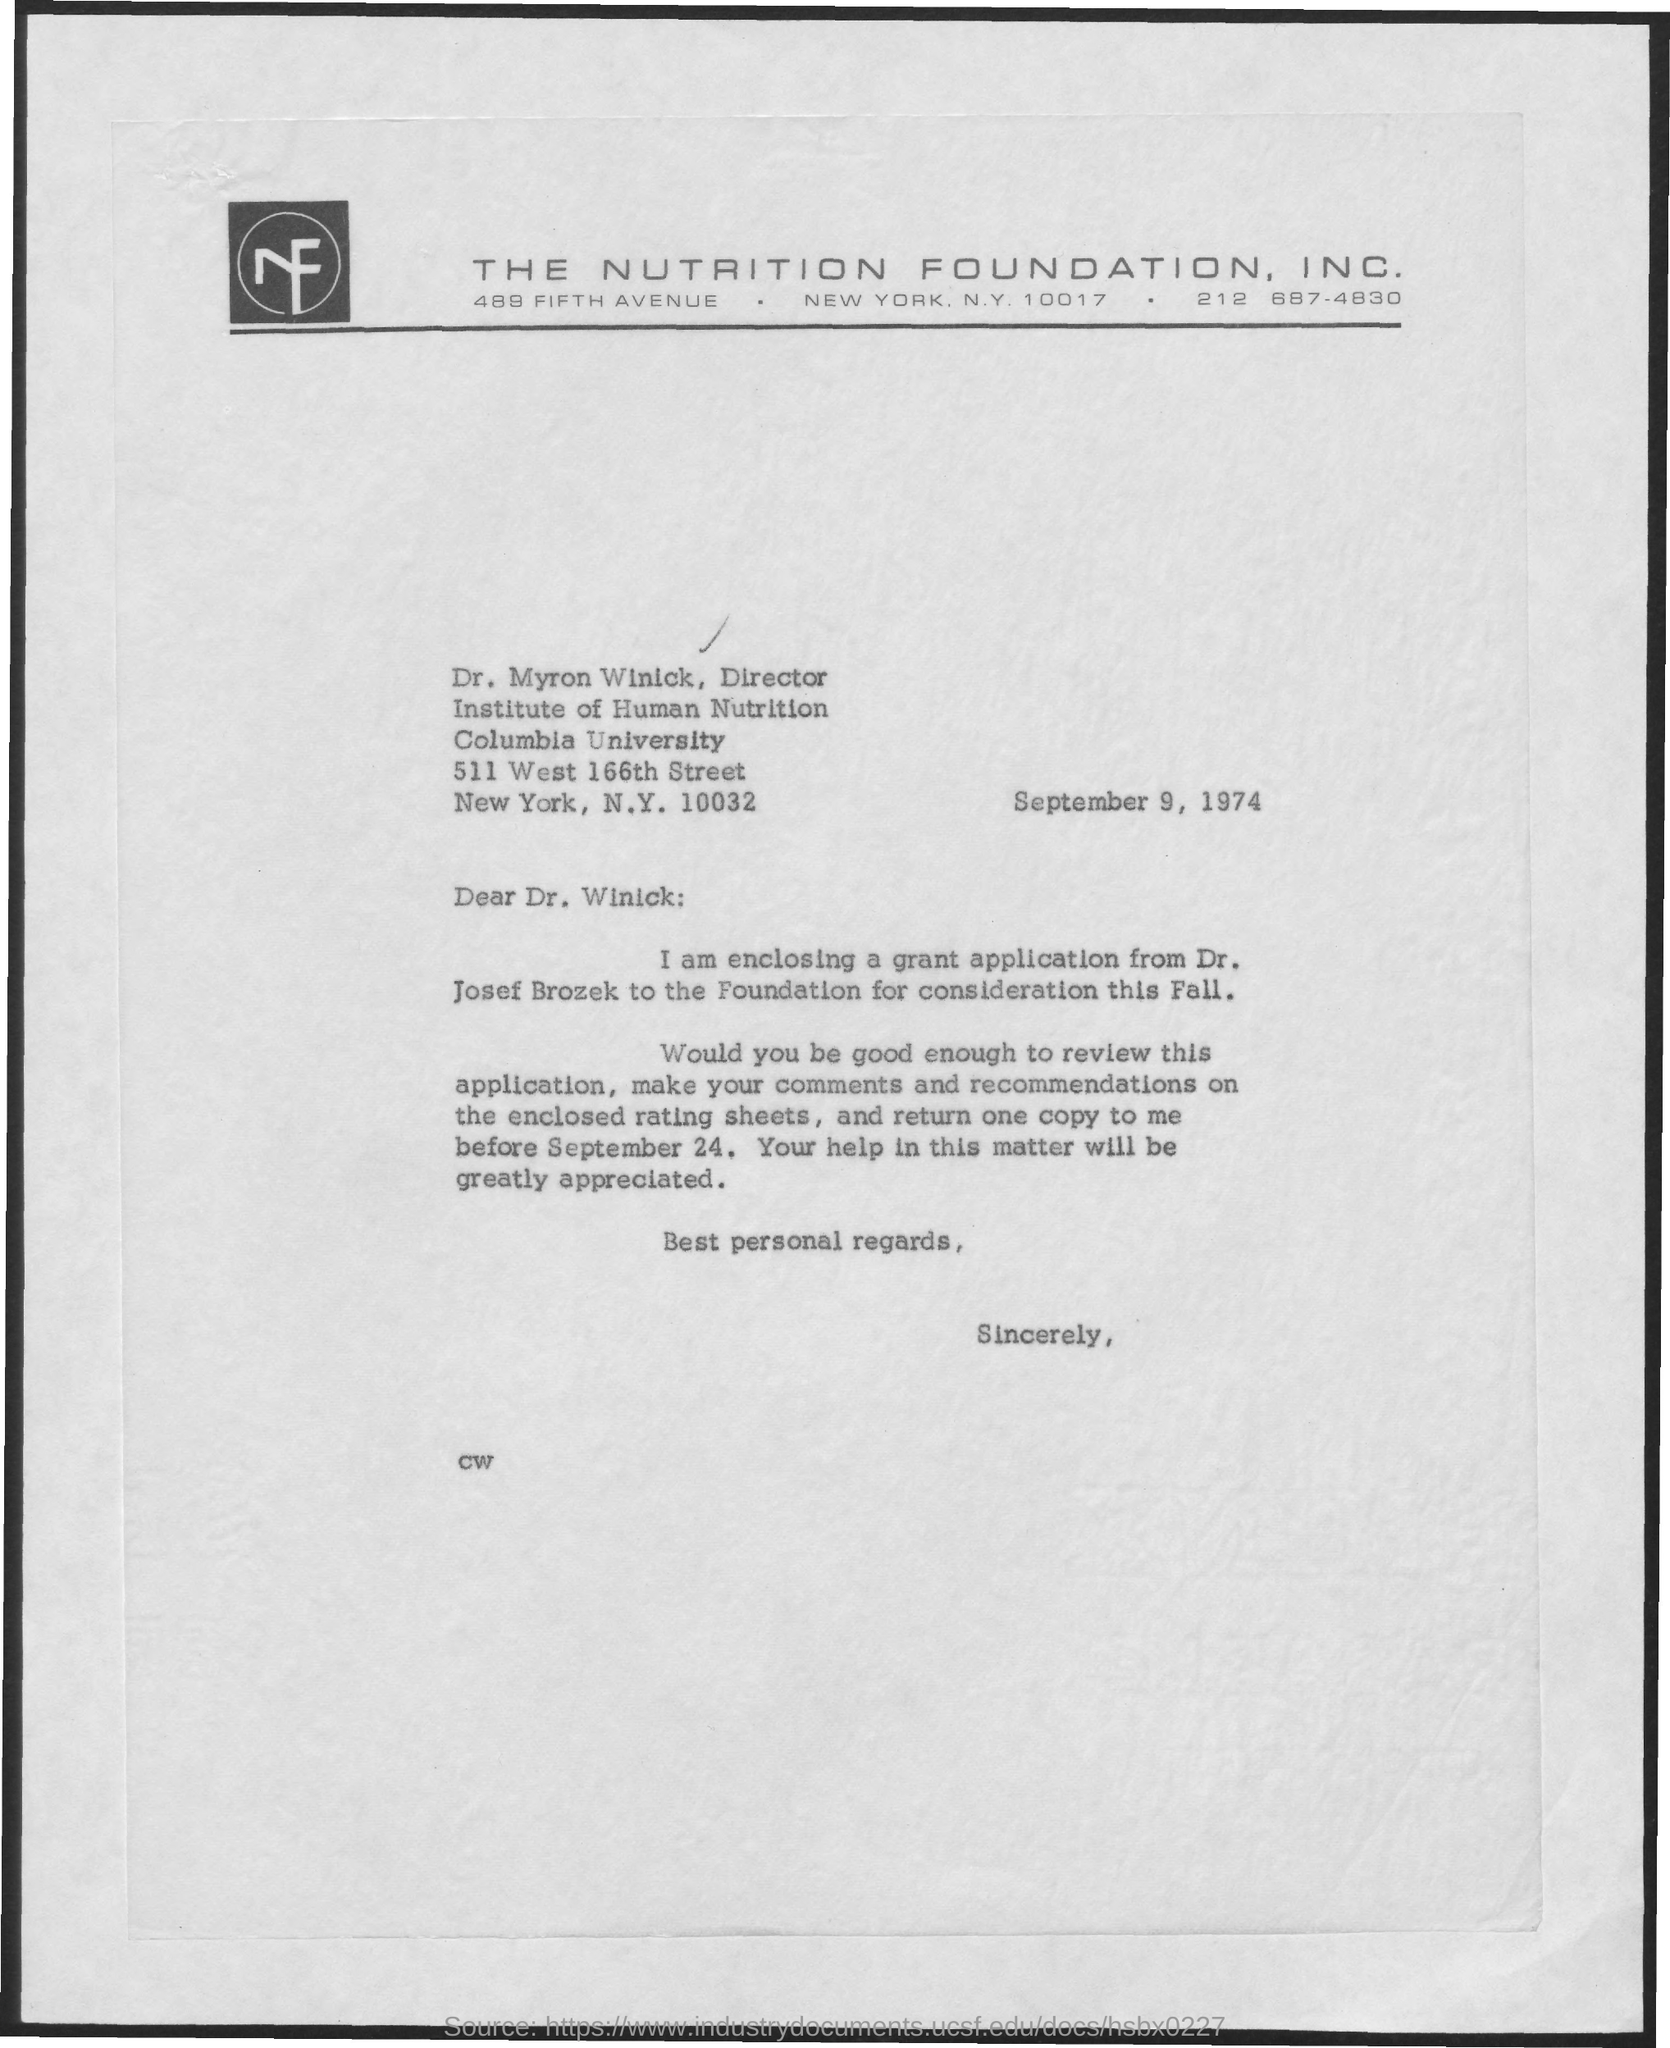Draw attention to some important aspects in this diagram. The document's date is September 9, 1974. The enclosed application belongs to Dr. Josef Brozek. 